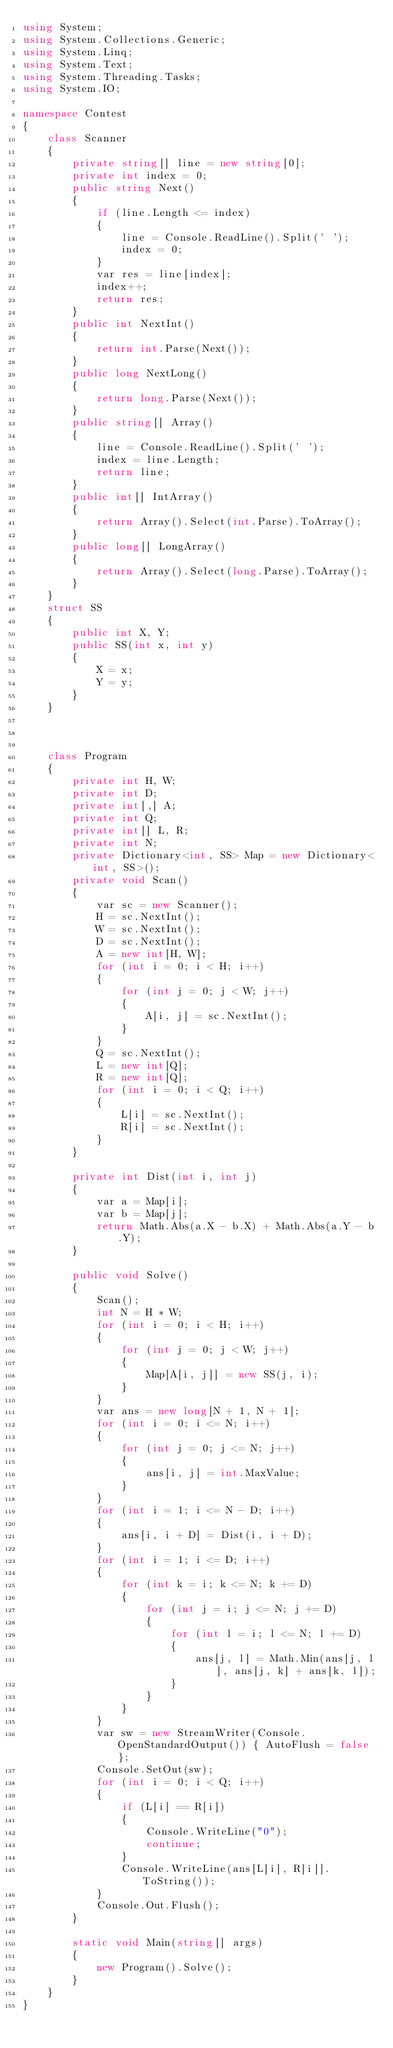<code> <loc_0><loc_0><loc_500><loc_500><_C#_>using System;
using System.Collections.Generic;
using System.Linq;
using System.Text;
using System.Threading.Tasks;
using System.IO;

namespace Contest
{
    class Scanner
    {
        private string[] line = new string[0];
        private int index = 0;
        public string Next()
        {
            if (line.Length <= index)
            {
                line = Console.ReadLine().Split(' ');
                index = 0;
            }
            var res = line[index];
            index++;
            return res;
        }
        public int NextInt()
        {
            return int.Parse(Next());
        }
        public long NextLong()
        {
            return long.Parse(Next());
        }
        public string[] Array()
        {
            line = Console.ReadLine().Split(' ');
            index = line.Length;
            return line;
        }
        public int[] IntArray()
        {
            return Array().Select(int.Parse).ToArray();
        }
        public long[] LongArray()
        {
            return Array().Select(long.Parse).ToArray();
        }
    }
    struct SS
    {
        public int X, Y;
        public SS(int x, int y)
        {
            X = x;
            Y = y;
        }
    }



    class Program
    {
        private int H, W;
        private int D;
        private int[,] A;
        private int Q;
        private int[] L, R;
        private int N;
        private Dictionary<int, SS> Map = new Dictionary<int, SS>();
        private void Scan()
        {
            var sc = new Scanner();
            H = sc.NextInt();
            W = sc.NextInt();
            D = sc.NextInt();
            A = new int[H, W];
            for (int i = 0; i < H; i++)
            {
                for (int j = 0; j < W; j++)
                {
                    A[i, j] = sc.NextInt();
                }
            }
            Q = sc.NextInt();
            L = new int[Q];
            R = new int[Q];
            for (int i = 0; i < Q; i++)
            {
                L[i] = sc.NextInt();
                R[i] = sc.NextInt();
            }
        }

        private int Dist(int i, int j)
        {
            var a = Map[i];
            var b = Map[j];
            return Math.Abs(a.X - b.X) + Math.Abs(a.Y - b.Y);
        }

        public void Solve()
        {
            Scan();
            int N = H * W;
            for (int i = 0; i < H; i++)
            {
                for (int j = 0; j < W; j++)
                {
                    Map[A[i, j]] = new SS(j, i);
                }
            }
            var ans = new long[N + 1, N + 1];
            for (int i = 0; i <= N; i++)
            {
                for (int j = 0; j <= N; j++)
                {
                    ans[i, j] = int.MaxValue;
                }
            }
            for (int i = 1; i <= N - D; i++)
            {
                ans[i, i + D] = Dist(i, i + D);
            }
            for (int i = 1; i <= D; i++)
            {
                for (int k = i; k <= N; k += D)
                {
                    for (int j = i; j <= N; j += D)
                    {
                        for (int l = i; l <= N; l += D)
                        {
                            ans[j, l] = Math.Min(ans[j, l], ans[j, k] + ans[k, l]);
                        }
                    }
                }
            }
            var sw = new StreamWriter(Console.OpenStandardOutput()) { AutoFlush = false };
            Console.SetOut(sw);
            for (int i = 0; i < Q; i++)
            {
                if (L[i] == R[i])
                {
                    Console.WriteLine("0");
                    continue;
                }
                Console.WriteLine(ans[L[i], R[i]].ToString());
            }
            Console.Out.Flush();
        }

        static void Main(string[] args)
        {
            new Program().Solve();
        }
    }
}</code> 